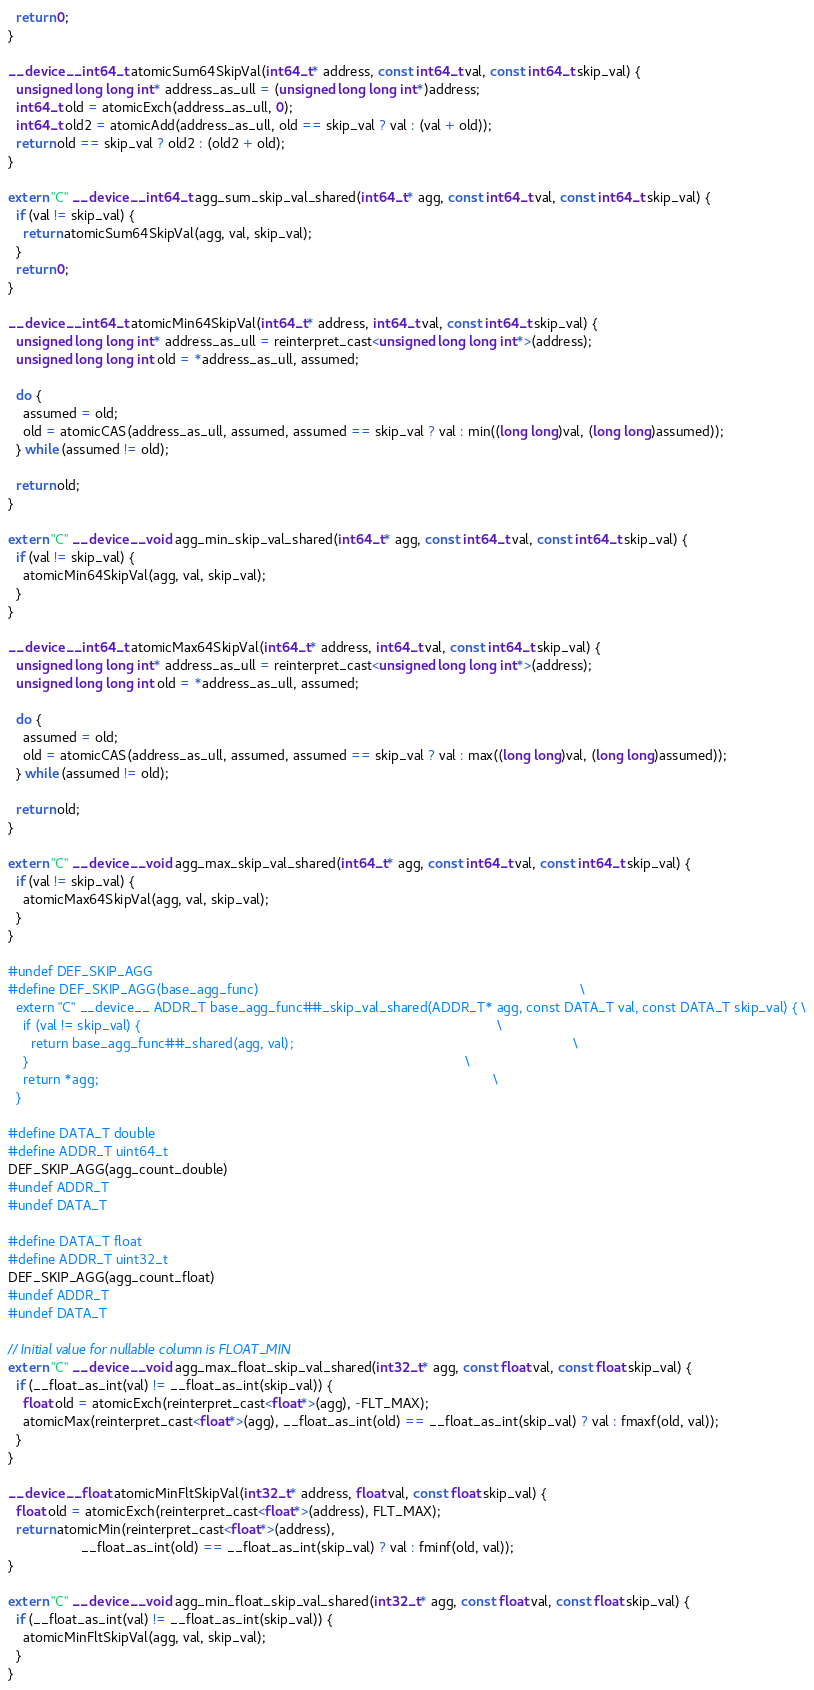<code> <loc_0><loc_0><loc_500><loc_500><_Cuda_>  return 0;
}

__device__ int64_t atomicSum64SkipVal(int64_t* address, const int64_t val, const int64_t skip_val) {
  unsigned long long int* address_as_ull = (unsigned long long int*)address;
  int64_t old = atomicExch(address_as_ull, 0);
  int64_t old2 = atomicAdd(address_as_ull, old == skip_val ? val : (val + old));
  return old == skip_val ? old2 : (old2 + old);
}

extern "C" __device__ int64_t agg_sum_skip_val_shared(int64_t* agg, const int64_t val, const int64_t skip_val) {
  if (val != skip_val) {
    return atomicSum64SkipVal(agg, val, skip_val);
  }
  return 0;
}

__device__ int64_t atomicMin64SkipVal(int64_t* address, int64_t val, const int64_t skip_val) {
  unsigned long long int* address_as_ull = reinterpret_cast<unsigned long long int*>(address);
  unsigned long long int old = *address_as_ull, assumed;

  do {
    assumed = old;
    old = atomicCAS(address_as_ull, assumed, assumed == skip_val ? val : min((long long)val, (long long)assumed));
  } while (assumed != old);

  return old;
}

extern "C" __device__ void agg_min_skip_val_shared(int64_t* agg, const int64_t val, const int64_t skip_val) {
  if (val != skip_val) {
    atomicMin64SkipVal(agg, val, skip_val);
  }
}

__device__ int64_t atomicMax64SkipVal(int64_t* address, int64_t val, const int64_t skip_val) {
  unsigned long long int* address_as_ull = reinterpret_cast<unsigned long long int*>(address);
  unsigned long long int old = *address_as_ull, assumed;

  do {
    assumed = old;
    old = atomicCAS(address_as_ull, assumed, assumed == skip_val ? val : max((long long)val, (long long)assumed));
  } while (assumed != old);

  return old;
}

extern "C" __device__ void agg_max_skip_val_shared(int64_t* agg, const int64_t val, const int64_t skip_val) {
  if (val != skip_val) {
    atomicMax64SkipVal(agg, val, skip_val);
  }
}

#undef DEF_SKIP_AGG
#define DEF_SKIP_AGG(base_agg_func)                                                                                    \
  extern "C" __device__ ADDR_T base_agg_func##_skip_val_shared(ADDR_T* agg, const DATA_T val, const DATA_T skip_val) { \
    if (val != skip_val) {                                                                                             \
      return base_agg_func##_shared(agg, val);                                                                         \
    }                                                                                                                  \
    return *agg;                                                                                                       \
  }

#define DATA_T double
#define ADDR_T uint64_t
DEF_SKIP_AGG(agg_count_double)
#undef ADDR_T
#undef DATA_T

#define DATA_T float
#define ADDR_T uint32_t
DEF_SKIP_AGG(agg_count_float)
#undef ADDR_T
#undef DATA_T

// Initial value for nullable column is FLOAT_MIN
extern "C" __device__ void agg_max_float_skip_val_shared(int32_t* agg, const float val, const float skip_val) {
  if (__float_as_int(val) != __float_as_int(skip_val)) {
    float old = atomicExch(reinterpret_cast<float*>(agg), -FLT_MAX);
    atomicMax(reinterpret_cast<float*>(agg), __float_as_int(old) == __float_as_int(skip_val) ? val : fmaxf(old, val));
  }
}

__device__ float atomicMinFltSkipVal(int32_t* address, float val, const float skip_val) {
  float old = atomicExch(reinterpret_cast<float*>(address), FLT_MAX);
  return atomicMin(reinterpret_cast<float*>(address),
                   __float_as_int(old) == __float_as_int(skip_val) ? val : fminf(old, val));
}

extern "C" __device__ void agg_min_float_skip_val_shared(int32_t* agg, const float val, const float skip_val) {
  if (__float_as_int(val) != __float_as_int(skip_val)) {
    atomicMinFltSkipVal(agg, val, skip_val);
  }
}
</code> 